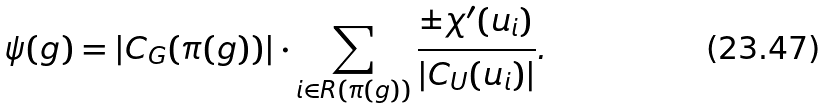Convert formula to latex. <formula><loc_0><loc_0><loc_500><loc_500>\psi ( g ) = | C _ { G } ( \pi ( g ) ) | \cdot \sum _ { i \in R ( \pi ( g ) ) } \frac { \pm \chi ^ { \prime } ( u _ { i } ) } { | C _ { U } ( u _ { i } ) | } .</formula> 